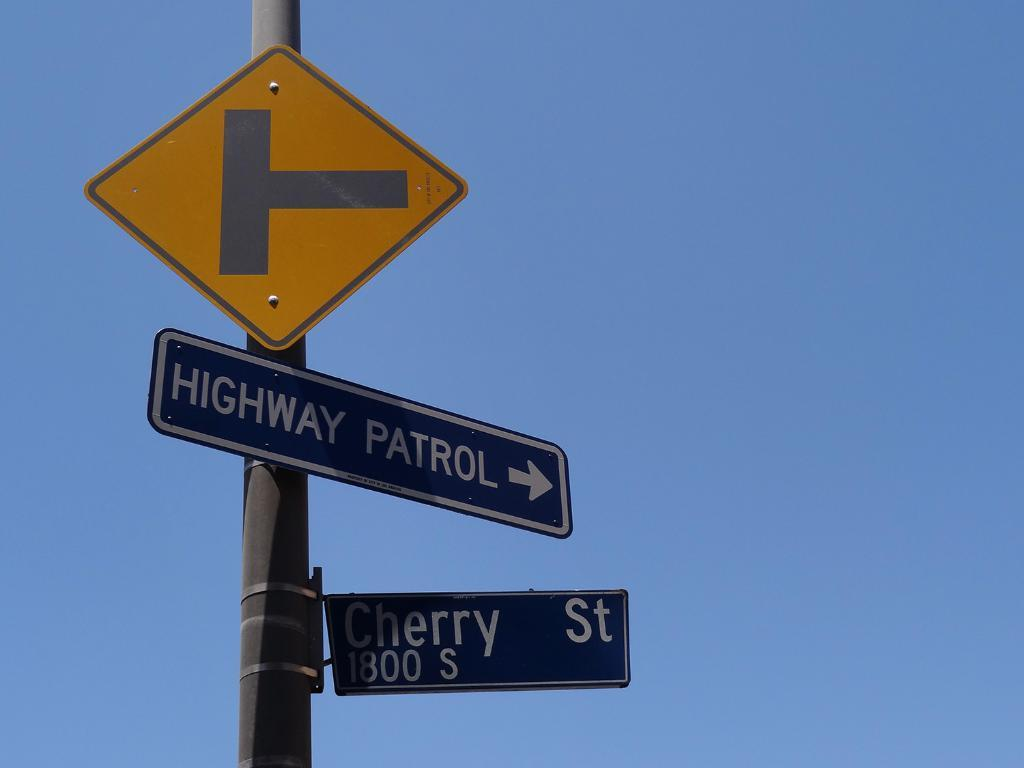<image>
Write a terse but informative summary of the picture. The intersection of Cherry Street shows where Highway Patrol is located. 